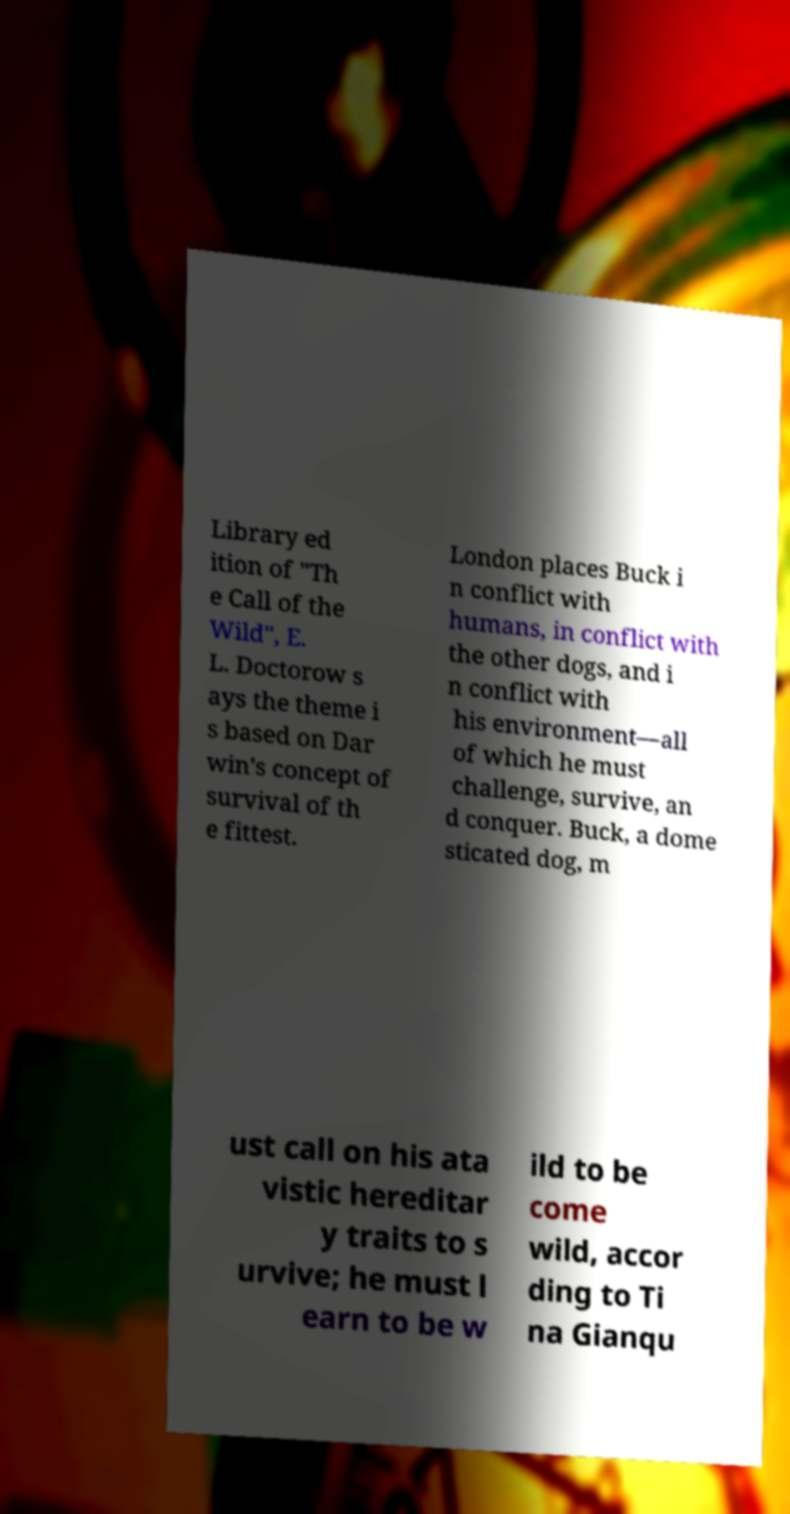Can you read and provide the text displayed in the image?This photo seems to have some interesting text. Can you extract and type it out for me? Library ed ition of "Th e Call of the Wild", E. L. Doctorow s ays the theme i s based on Dar win's concept of survival of th e fittest. London places Buck i n conflict with humans, in conflict with the other dogs, and i n conflict with his environment—all of which he must challenge, survive, an d conquer. Buck, a dome sticated dog, m ust call on his ata vistic hereditar y traits to s urvive; he must l earn to be w ild to be come wild, accor ding to Ti na Gianqu 